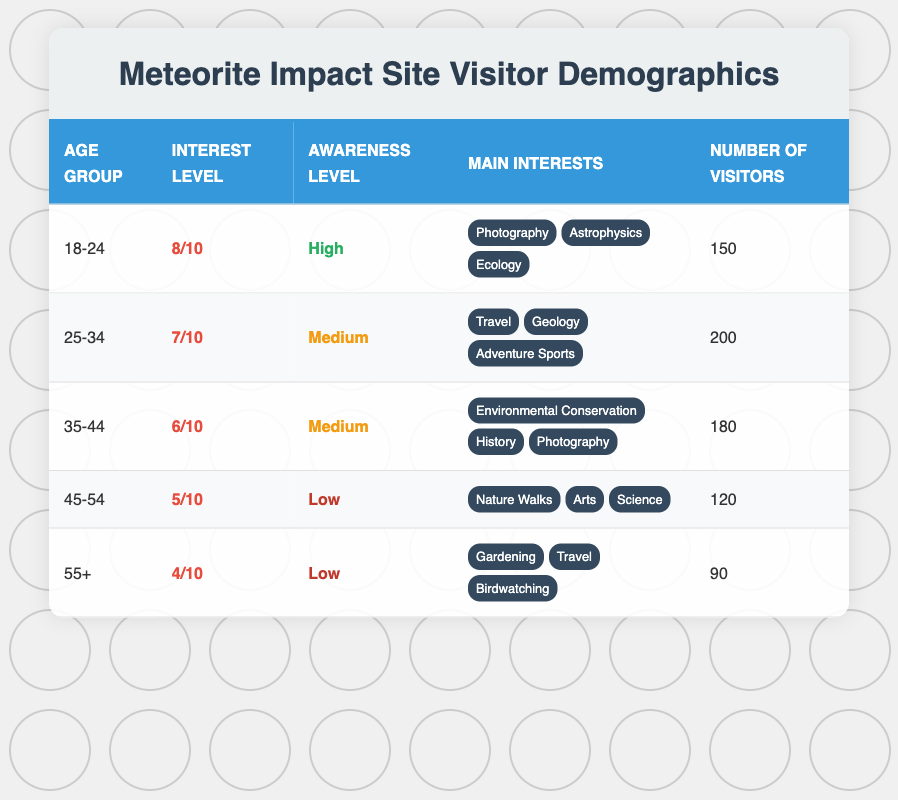What is the average interest level of visitors aged 25-34? The interest level for the age group 25-34 is listed as 7 out of 10.
Answer: 7 How many visitors are there in the age group 45-54? The number of visitors in the age group 45-54 is explicitly mentioned in the table as 120.
Answer: 120 What is the total number of visitors across all age groups? To find the total number of visitors, add the number of visitors from each age group: 150 (18-24) + 200 (25-34) + 180 (35-44) + 120 (45-54) + 90 (55+) = 840.
Answer: 840 Is the awareness level for the 55+ age group high? The awareness level for the age group 55+ is marked as Low in the table. Therefore, the statement is false.
Answer: No Which age group has the highest average interest level? The age group 18-24 has the highest average interest level at 8 out of 10, which can be compared to the other levels listed in the table.
Answer: 18-24 How many of the visitors aged 35-44 have a medium awareness level? The table shows that the awareness level for visitors aged 35-44 is Medium, with a total of 180 visitors in this age group.
Answer: 180 What is the average interest level for visitors in the age groups with low awareness levels combined? The average interest level for the age groups 45-54 and 55+ is (5 + 4)/2 = 4.5. Therefore, this is calculated as the sum of their interest levels divided by the number of these groups, which is 2.
Answer: 4.5 How many more visitors are there in the age group 25-34 compared to the age group 55+? To determine the difference in visitors between these two age groups: 200 (25-34) - 90 (55+) = 110 more visitors.
Answer: 110 Which age group has the lowest average interest level? The age group 55+ has the lowest average interest level, at 4 out of 10, which is clearly stated in the table.
Answer: 55+ 